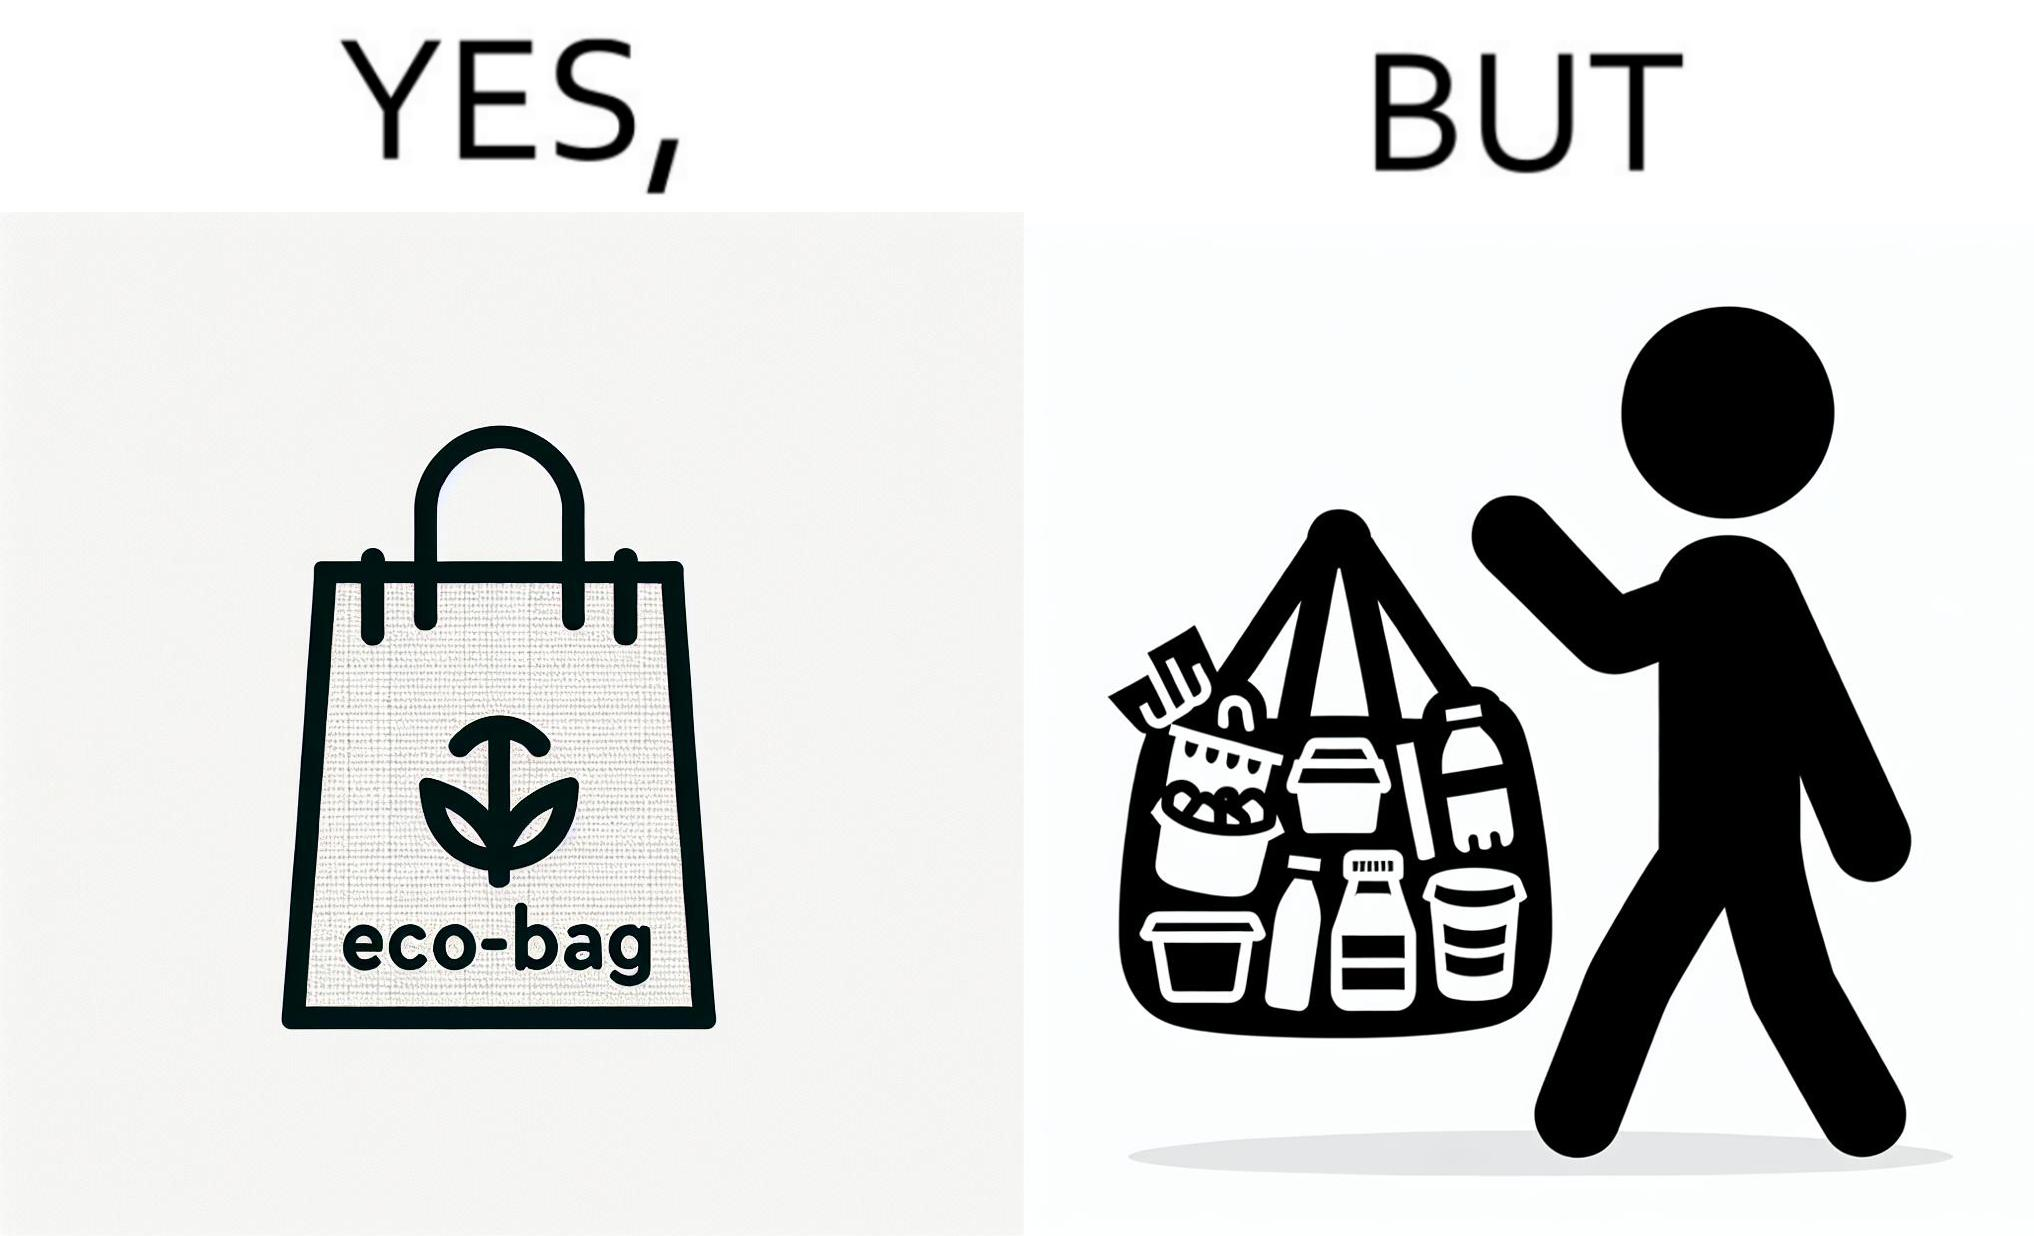Describe the content of this image. The image is ironic, because people nowadays use eco-bag thinking them as safe for the environment but in turn use products which are harmful for the environment or are packaged in some non-biodegradable material 